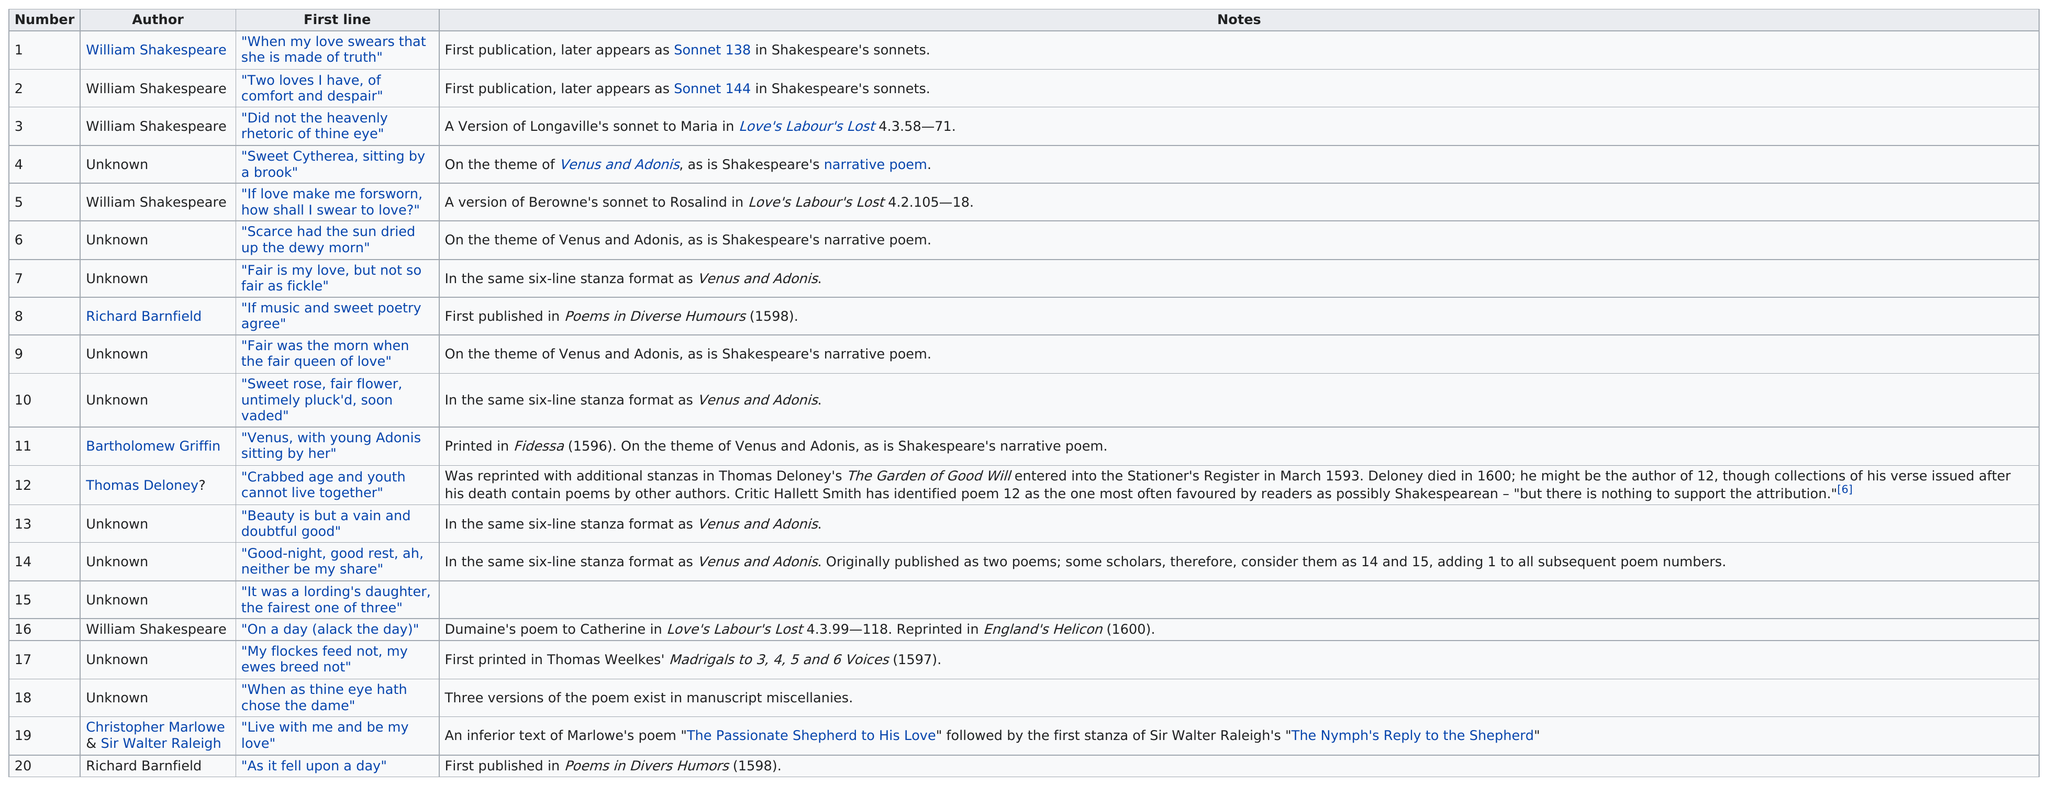List a handful of essential elements in this visual. In the 1599 edition, William Shakespeare is the most prominent author. Richard Barnfield, the author, has a poem with the first line "as it fell upon day" and another poem that begins with "if music and sweet poetry agree. William Shakespeare wrote the works "Two Loves I Have, of Comfort and Despair," and "On a Day (Alack the Day). Approximately 50% of the poems are written by unknown authors," or "A significant portion, approximately 50%, of the poems are written by unknown authors. 